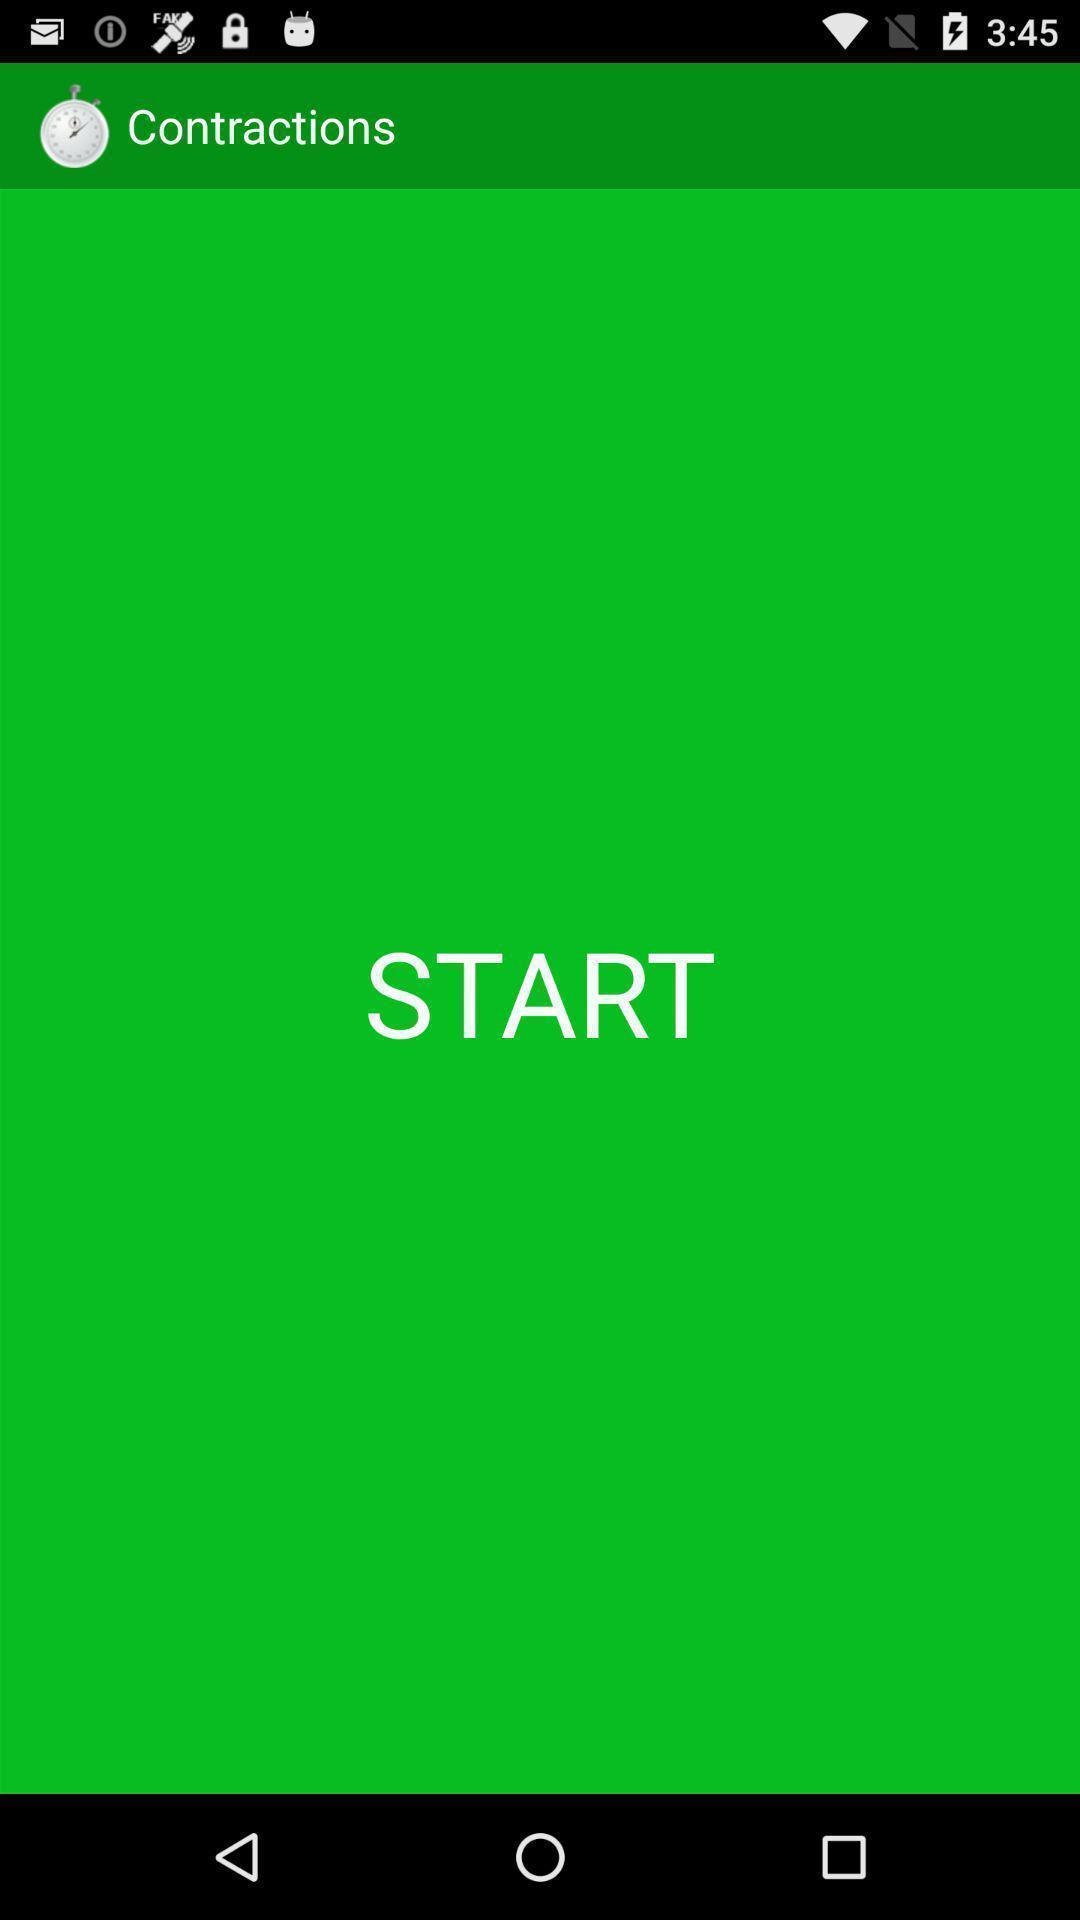Describe the visual elements of this screenshot. Startup page of the application. 